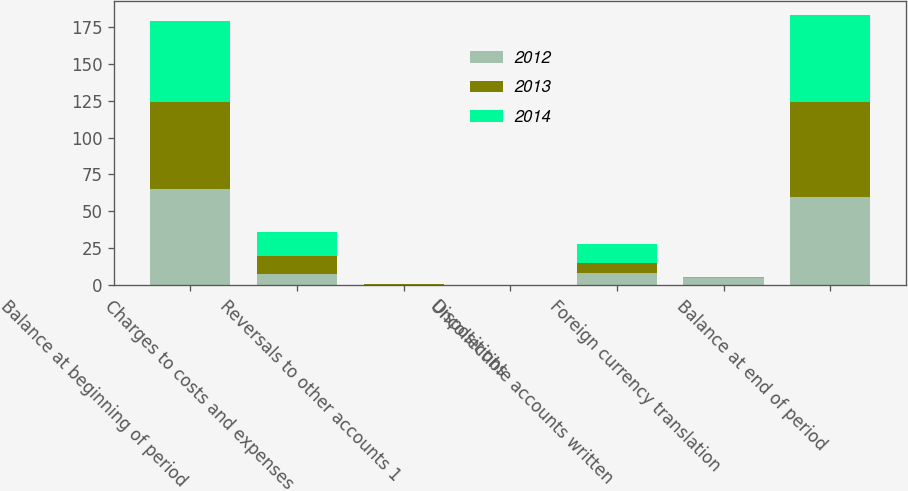Convert chart to OTSL. <chart><loc_0><loc_0><loc_500><loc_500><stacked_bar_chart><ecel><fcel>Balance at beginning of period<fcel>Charges to costs and expenses<fcel>Reversals to other accounts 1<fcel>Dispositions<fcel>Uncollectible accounts written<fcel>Foreign currency translation<fcel>Balance at end of period<nl><fcel>2012<fcel>64.9<fcel>7.4<fcel>0.1<fcel>0<fcel>8.1<fcel>4.8<fcel>59.5<nl><fcel>2013<fcel>59<fcel>12.6<fcel>0.7<fcel>0<fcel>7.2<fcel>0.2<fcel>64.9<nl><fcel>2014<fcel>55.4<fcel>16.3<fcel>0.2<fcel>0.4<fcel>12.6<fcel>0.5<fcel>59<nl></chart> 